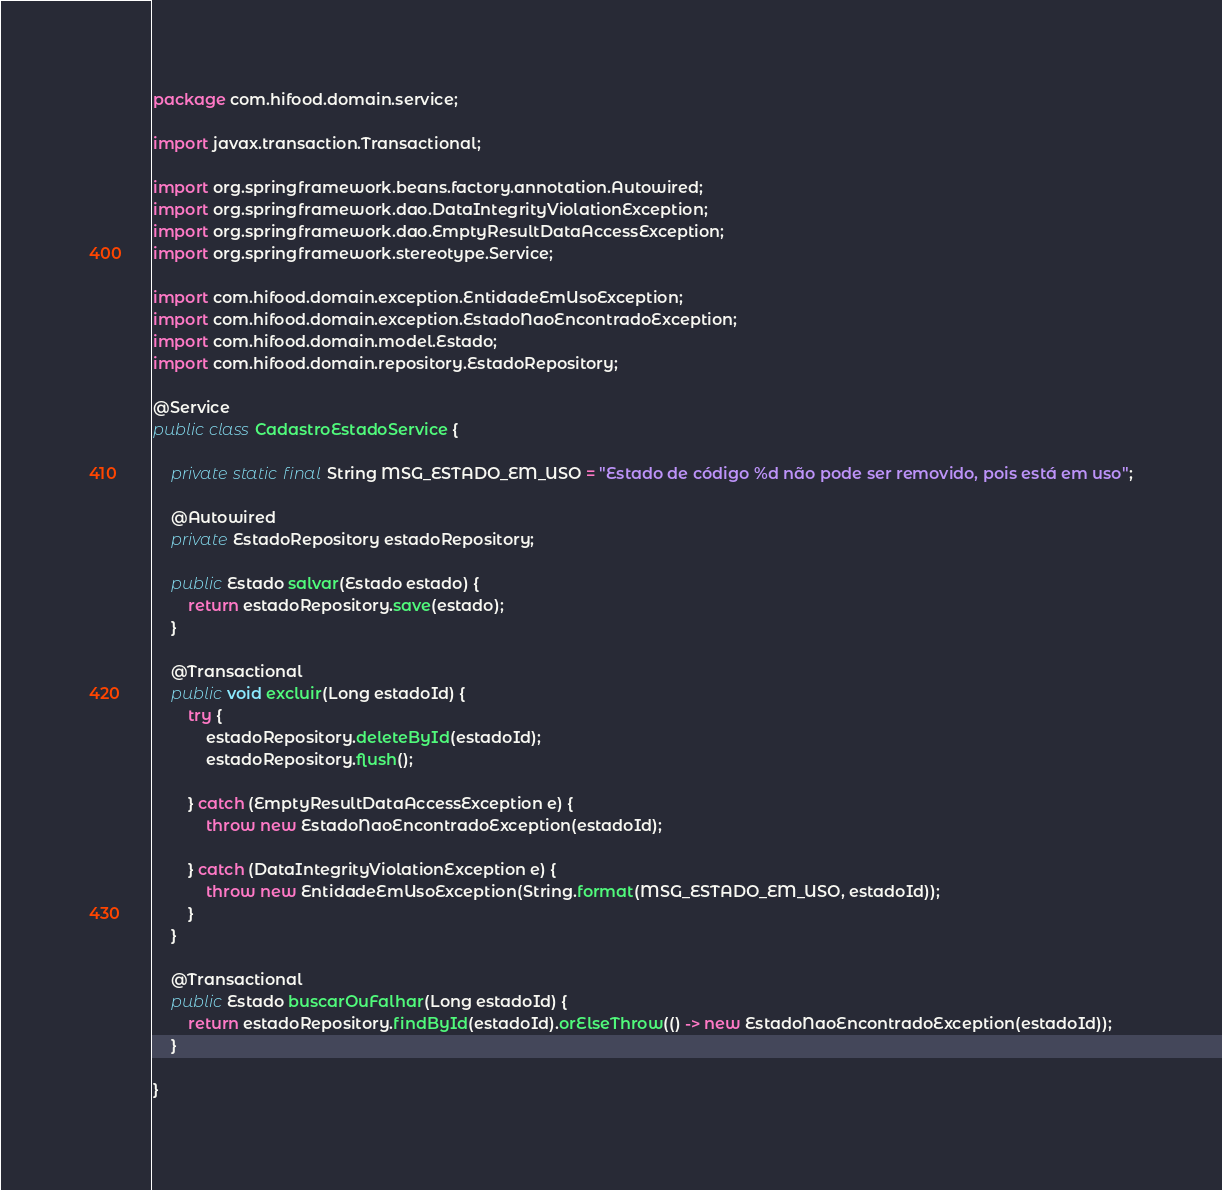<code> <loc_0><loc_0><loc_500><loc_500><_Java_>package com.hifood.domain.service;

import javax.transaction.Transactional;

import org.springframework.beans.factory.annotation.Autowired;
import org.springframework.dao.DataIntegrityViolationException;
import org.springframework.dao.EmptyResultDataAccessException;
import org.springframework.stereotype.Service;

import com.hifood.domain.exception.EntidadeEmUsoException;
import com.hifood.domain.exception.EstadoNaoEncontradoException;
import com.hifood.domain.model.Estado;
import com.hifood.domain.repository.EstadoRepository;

@Service
public class CadastroEstadoService {

    private static final String MSG_ESTADO_EM_USO = "Estado de código %d não pode ser removido, pois está em uso";

    @Autowired
    private EstadoRepository estadoRepository;

    public Estado salvar(Estado estado) {
        return estadoRepository.save(estado);
    }

    @Transactional
    public void excluir(Long estadoId) {
        try {
            estadoRepository.deleteById(estadoId);
            estadoRepository.flush();

        } catch (EmptyResultDataAccessException e) {
            throw new EstadoNaoEncontradoException(estadoId);

        } catch (DataIntegrityViolationException e) {
            throw new EntidadeEmUsoException(String.format(MSG_ESTADO_EM_USO, estadoId));
        }
    }

    @Transactional
    public Estado buscarOuFalhar(Long estadoId) {
        return estadoRepository.findById(estadoId).orElseThrow(() -> new EstadoNaoEncontradoException(estadoId));
    }

}
</code> 